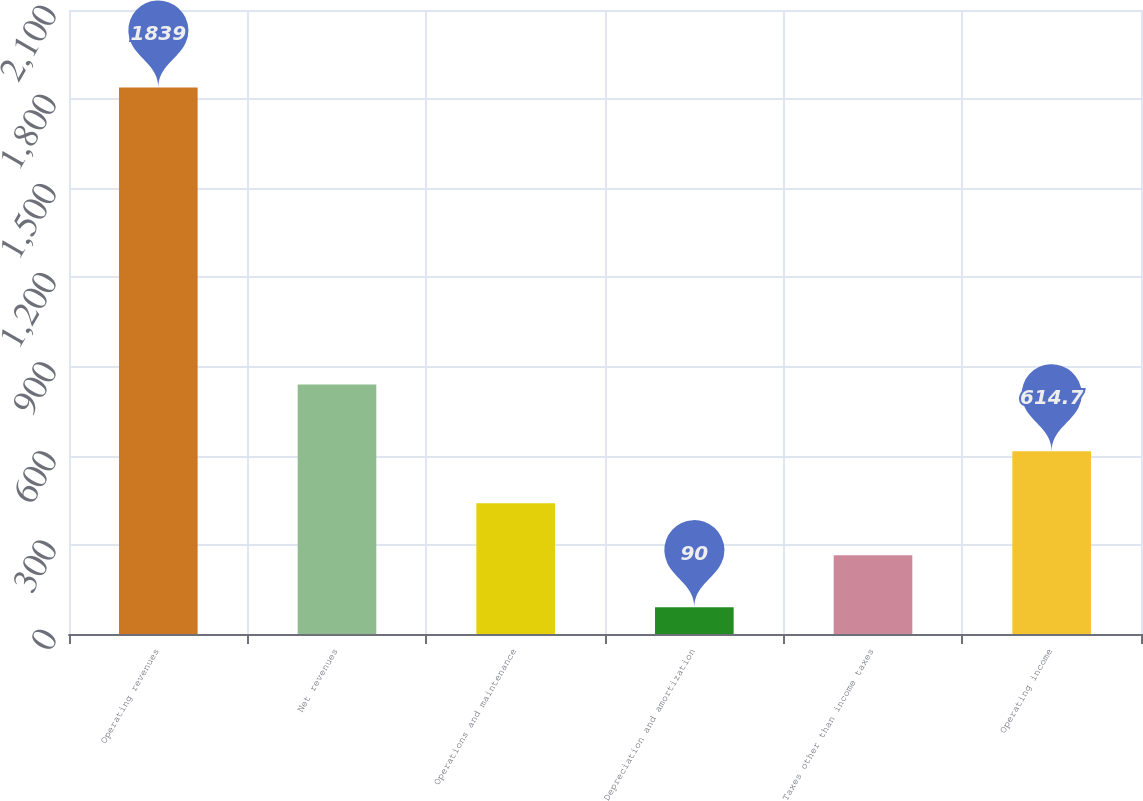<chart> <loc_0><loc_0><loc_500><loc_500><bar_chart><fcel>Operating revenues<fcel>Net revenues<fcel>Operations and maintenance<fcel>Depreciation and amortization<fcel>Taxes other than income taxes<fcel>Operating income<nl><fcel>1839<fcel>840<fcel>439.8<fcel>90<fcel>264.9<fcel>614.7<nl></chart> 